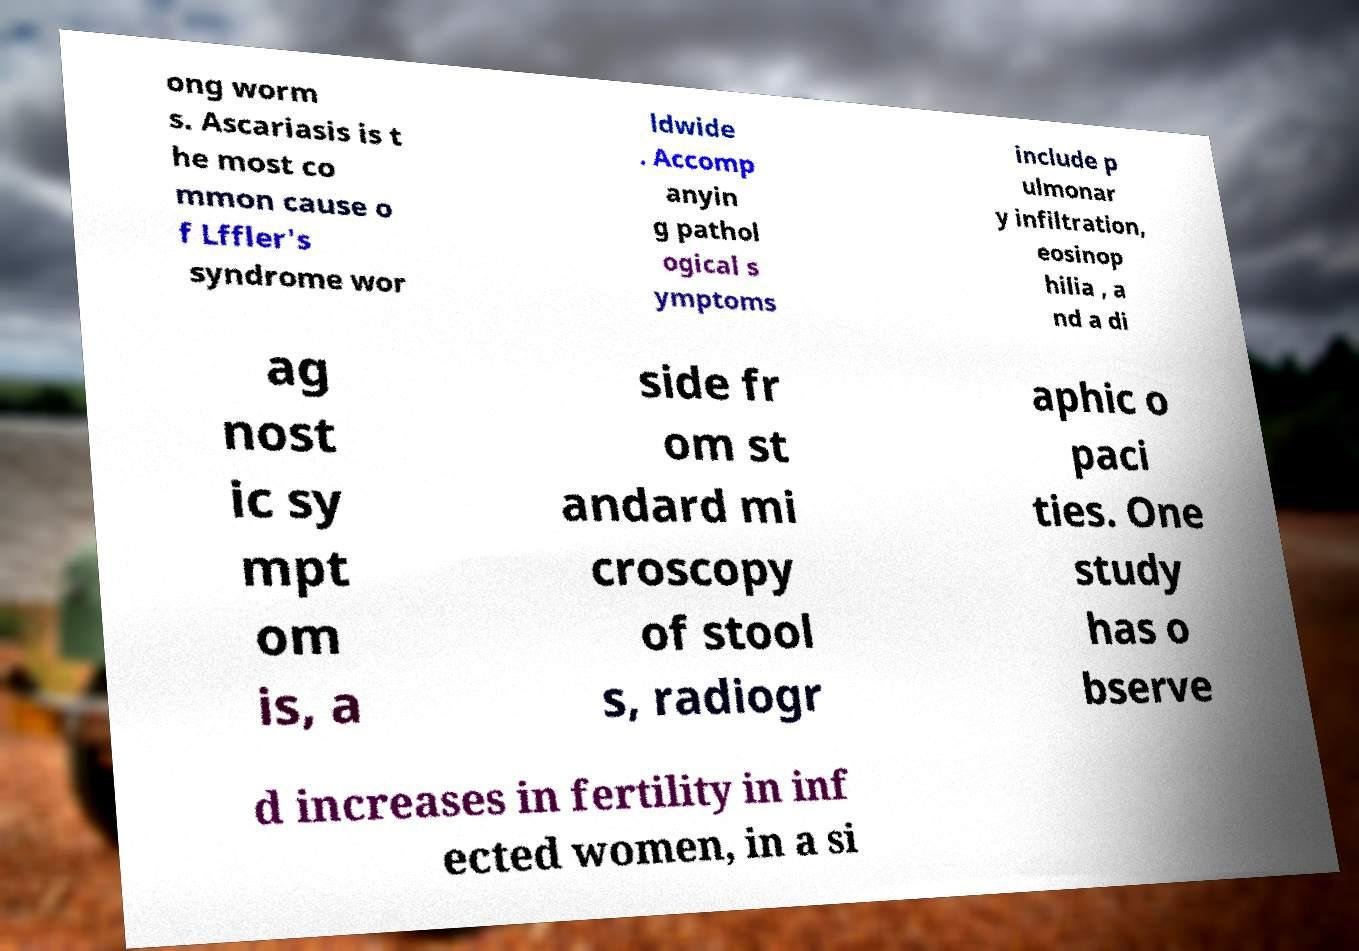Can you read and provide the text displayed in the image?This photo seems to have some interesting text. Can you extract and type it out for me? ong worm s. Ascariasis is t he most co mmon cause o f Lffler's syndrome wor ldwide . Accomp anyin g pathol ogical s ymptoms include p ulmonar y infiltration, eosinop hilia , a nd a di ag nost ic sy mpt om is, a side fr om st andard mi croscopy of stool s, radiogr aphic o paci ties. One study has o bserve d increases in fertility in inf ected women, in a si 